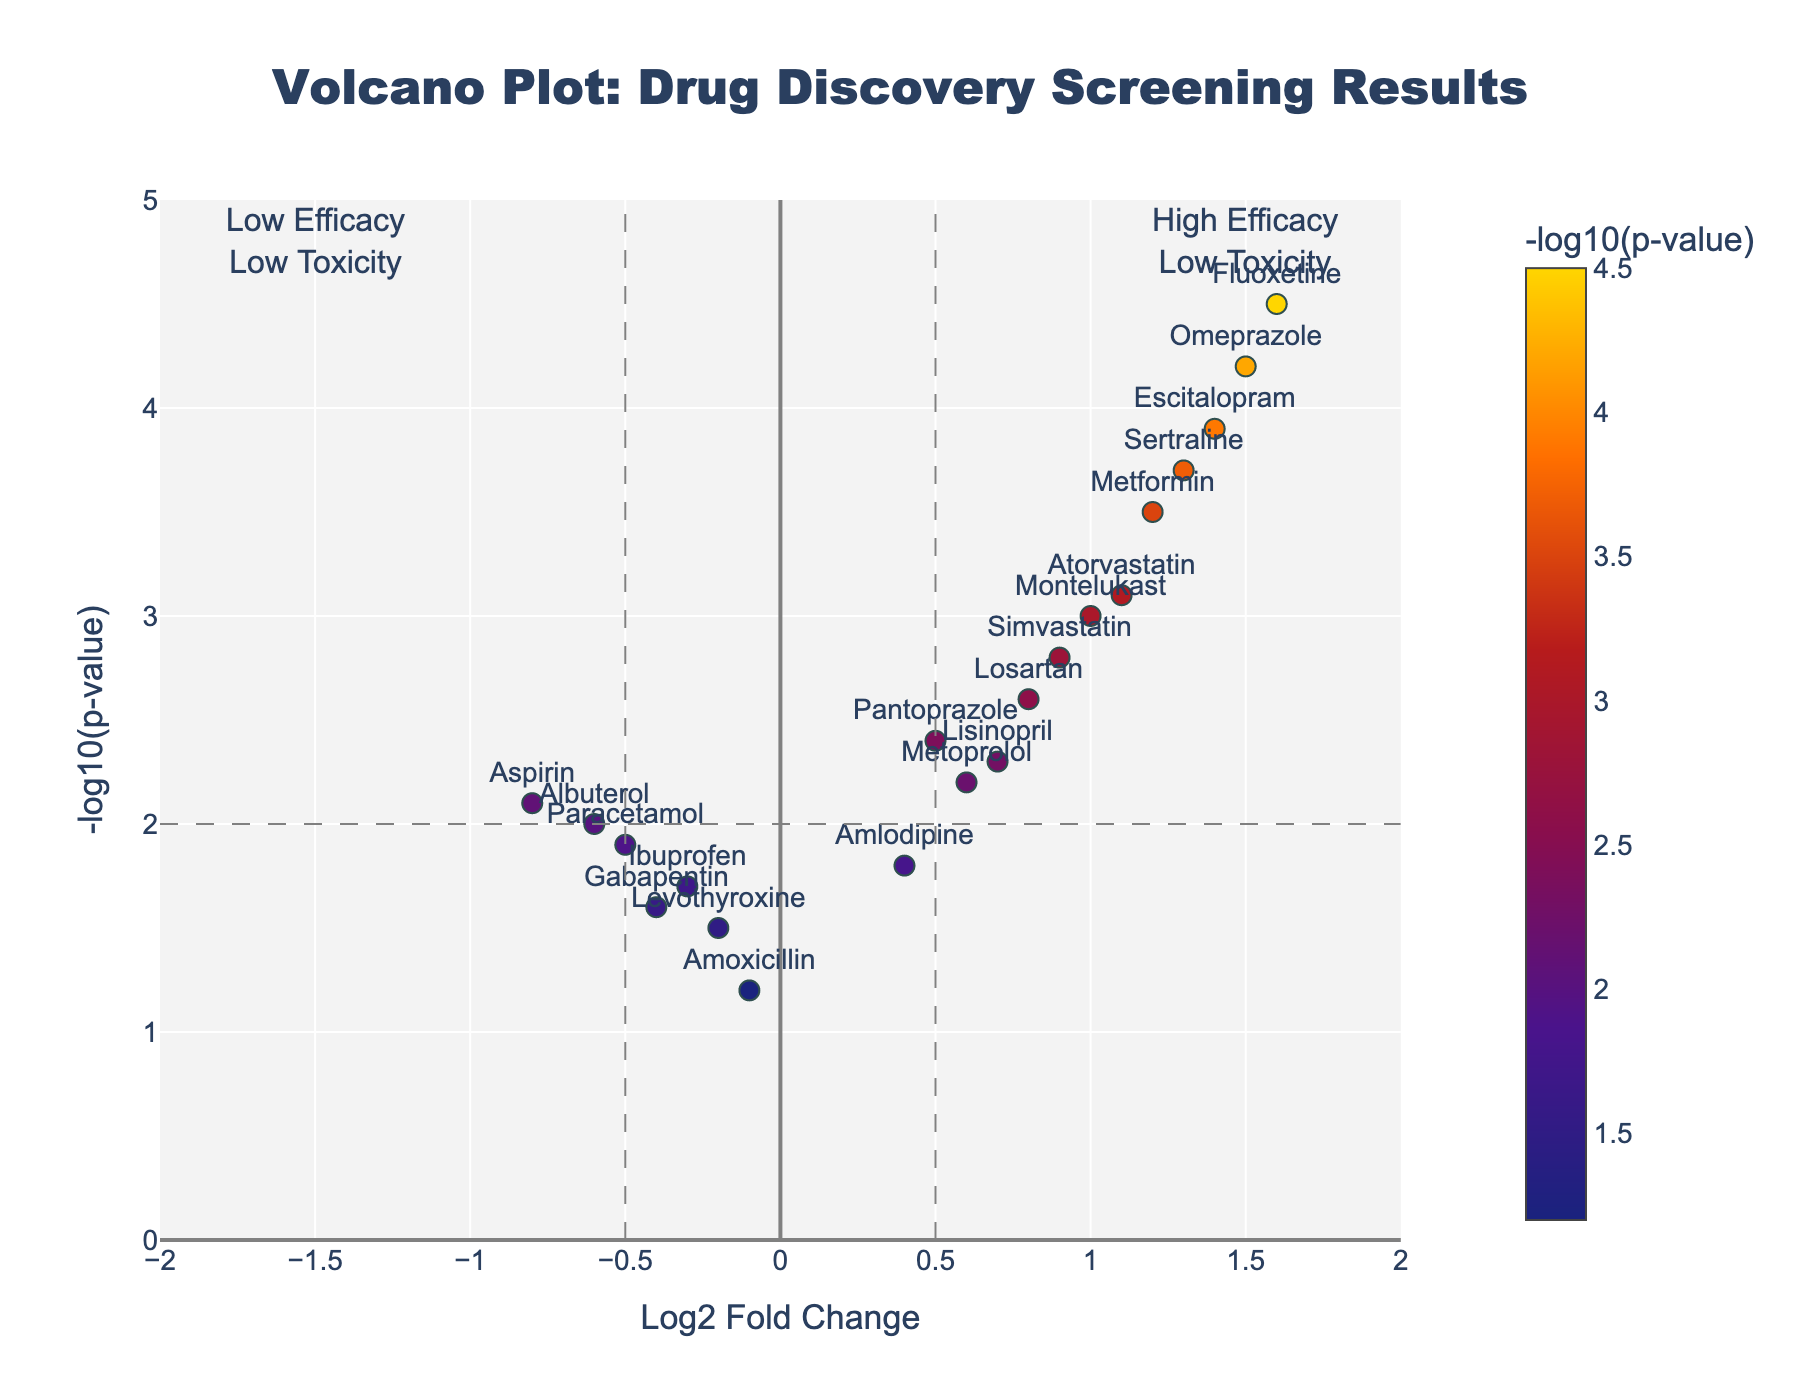What's the title of the plot? The title is usually displayed at the top of the figure. In this case, the title is "Volcano Plot: Drug Discovery Screening Results".
Answer: "Volcano Plot: Drug Discovery Screening Results" How many compounds are displayed in the plot? There are individual markers for each compound in the scatter plot. Counting these markers provides the number of compounds.
Answer: 20 Which compound has the highest efficacy and lowest toxicity? To find the highest efficacy and lowest toxicity compound, identify the one with the highest Log2FoldChange and the highest NegativeLog10PValue. "Fluoxetine" is seen with Log2FoldChange of 1.6 and NegativeLog10PValue of 4.5.
Answer: Fluoxetine Which compound shows the lowest efficacy but is still significant in terms of low toxicity? Look for a compound with a negative Log2FoldChange (indicating lower efficacy) but high NegativeLog10PValue (low toxicity). "Aspirin" stands out with Log2FoldChange of -0.8 and NegativeLog10PValue of 2.1.
Answer: Aspirin What are the Log2 Fold Change thresholds marked on the plot? The vertical lines on the plot represent the Log2 Fold Change thresholds, which are -0.5 and 0.5.
Answer: -0.5 and 0.5 How many compounds have a Log2 Fold Change greater than 1? Identify the markers on the plot where Log2FoldChange > 1. Counting these gives the number of such compounds. The compounds are Omeprazole, Sertraline, Escitalopram, and Fluoxetine.
Answer: 4 Which compound has the highest Negative Log10 P-Value? The compound with the highest marker on the y-axis of the plot has the highest Negative Log10 P-Value. "Fluoxetine" is at the top with a value of 4.5.
Answer: Fluoxetine How many compounds have significant efficacy (Log2FoldChange > 0.5) and low toxicity (NegativeLog10PValue > 2)? Count the markers satisfying the condition Log2FoldChange > 0.5 and NegativeLog10PValue > 2. The compounds are Metformin, Simvastatin, Lisinopril, Omeprazole, Atorvastatin, Sertraline, Losartan, Escitalopram, Montelukast, Pantoprazole, Fluoxetine.
Answer: 11 Which compounds have a p-value threshold of less than 0.05? Since NegativeLog10PValue of 2 corresponds to a p-value of 0.01, any compound with a NegativeLog10PValue > 2 has a p-value threshold of less than 0.05. Multiple compounds such as Metformin, Simvastatin, etc., meet this condition. Count and list them.
Answer: 11 What is the top quadrant (high efficacy and low toxicity) annotation in the plot? Look at the annotation text in the top middle of the plot quadrant for high efficacy and low toxicity. It reads "High Efficacy<br>Low Toxicity".
Answer: High Efficacy\nLow Toxicity 